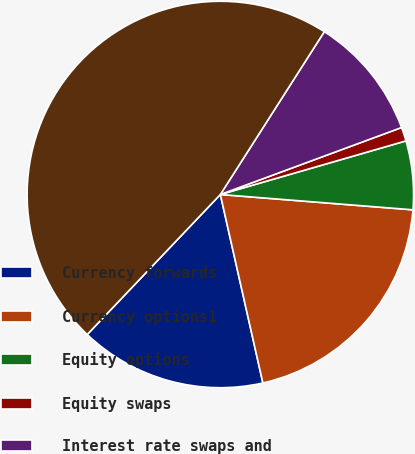Convert chart. <chart><loc_0><loc_0><loc_500><loc_500><pie_chart><fcel>Currency forwards<fcel>Currency options1<fcel>Equity options<fcel>Equity swaps<fcel>Interest rate swaps and<fcel>Total<nl><fcel>15.63%<fcel>20.2%<fcel>5.74%<fcel>1.16%<fcel>10.32%<fcel>46.94%<nl></chart> 